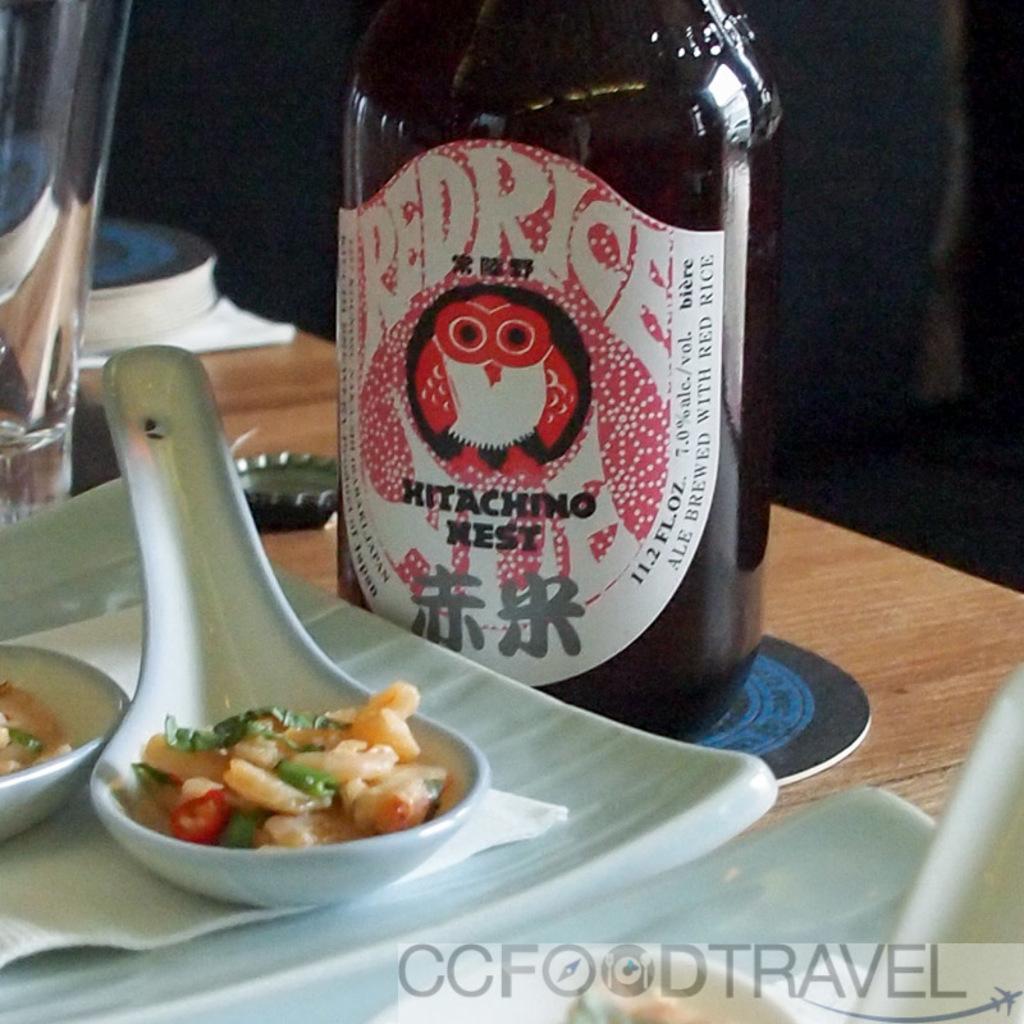What ingredient was the ale brewed with?
Ensure brevity in your answer.  Red rice. 